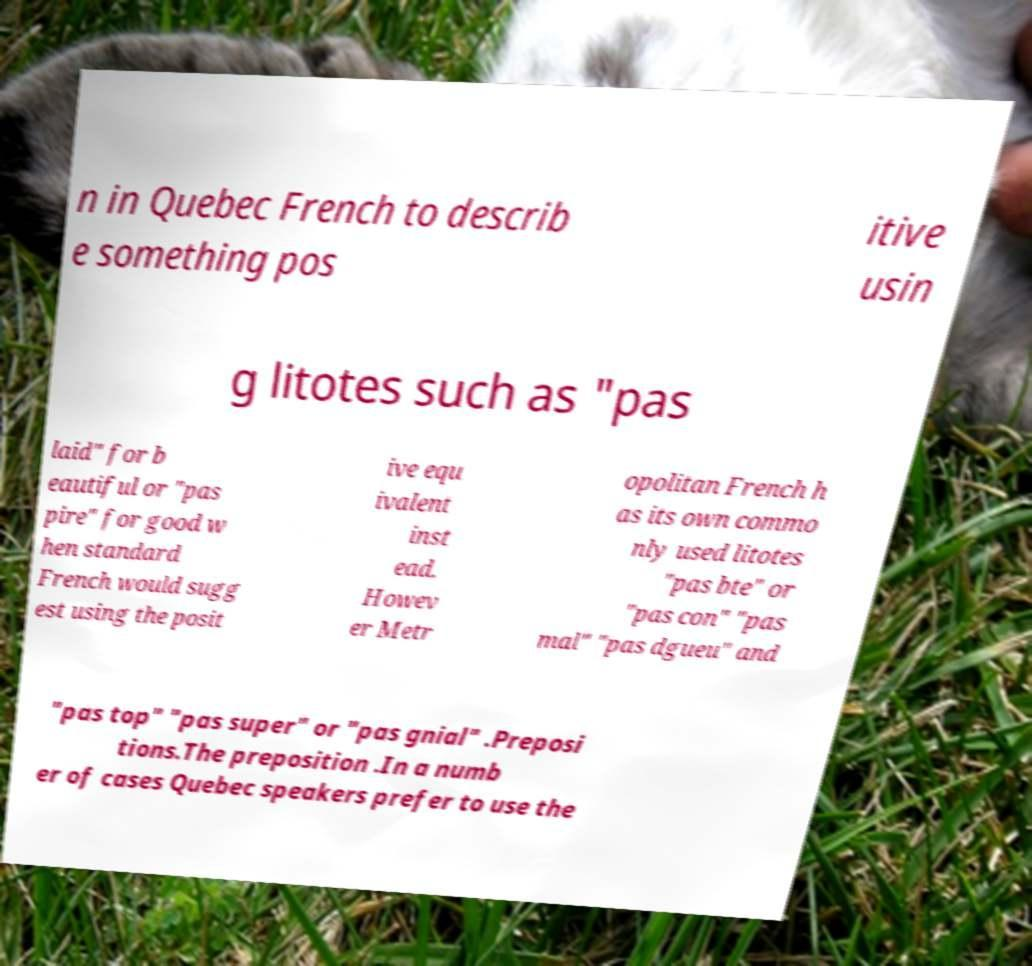What messages or text are displayed in this image? I need them in a readable, typed format. n in Quebec French to describ e something pos itive usin g litotes such as "pas laid" for b eautiful or "pas pire" for good w hen standard French would sugg est using the posit ive equ ivalent inst ead. Howev er Metr opolitan French h as its own commo nly used litotes "pas bte" or "pas con" "pas mal" "pas dgueu" and "pas top" "pas super" or "pas gnial" .Preposi tions.The preposition .In a numb er of cases Quebec speakers prefer to use the 